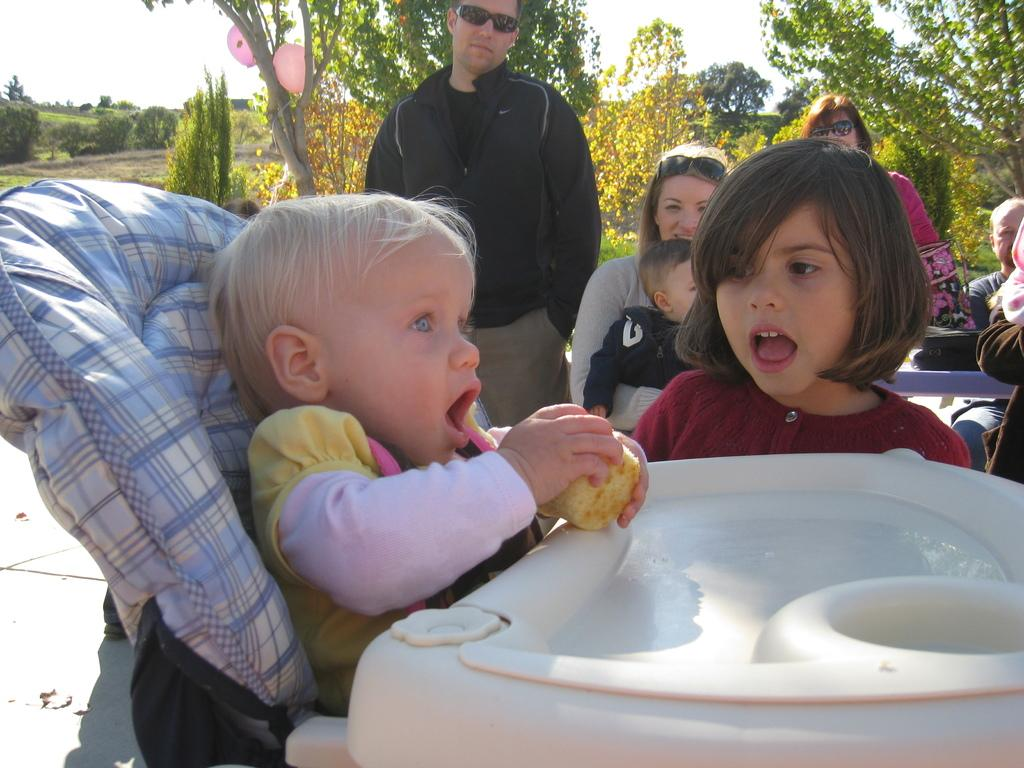What is the main subject of the image? The main subject of the image is a kid. Where is the kid sitting in the image? The kid is sitting on a dining chair. What can be seen in the background of the image? Trees and the sky are visible in the background of the image. Are there any other people in the image besides the kid? Yes, there are people in the image. What decorative items are present in the image? Balloons are present in the image. What type of oil can be seen dripping from the branch in the image? There is no branch or oil present in the image. What are the people in the image talking about? The image does not provide any information about what the people are talking about. 